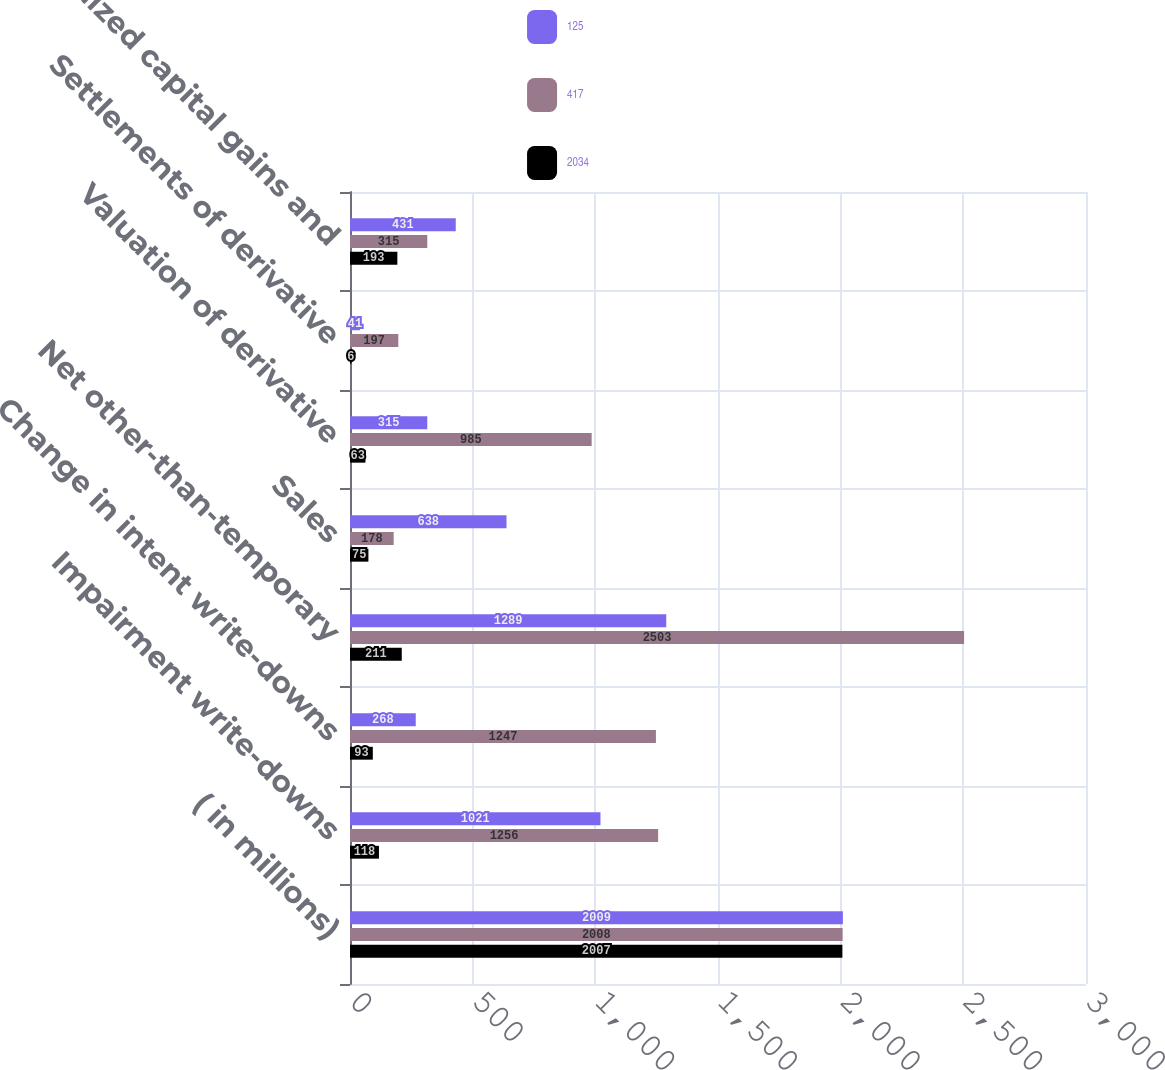<chart> <loc_0><loc_0><loc_500><loc_500><stacked_bar_chart><ecel><fcel>( in millions)<fcel>Impairment write-downs<fcel>Change in intent write-downs<fcel>Net other-than-temporary<fcel>Sales<fcel>Valuation of derivative<fcel>Settlements of derivative<fcel>Realized capital gains and<nl><fcel>125<fcel>2009<fcel>1021<fcel>268<fcel>1289<fcel>638<fcel>315<fcel>41<fcel>431<nl><fcel>417<fcel>2008<fcel>1256<fcel>1247<fcel>2503<fcel>178<fcel>985<fcel>197<fcel>315<nl><fcel>2034<fcel>2007<fcel>118<fcel>93<fcel>211<fcel>75<fcel>63<fcel>6<fcel>193<nl></chart> 